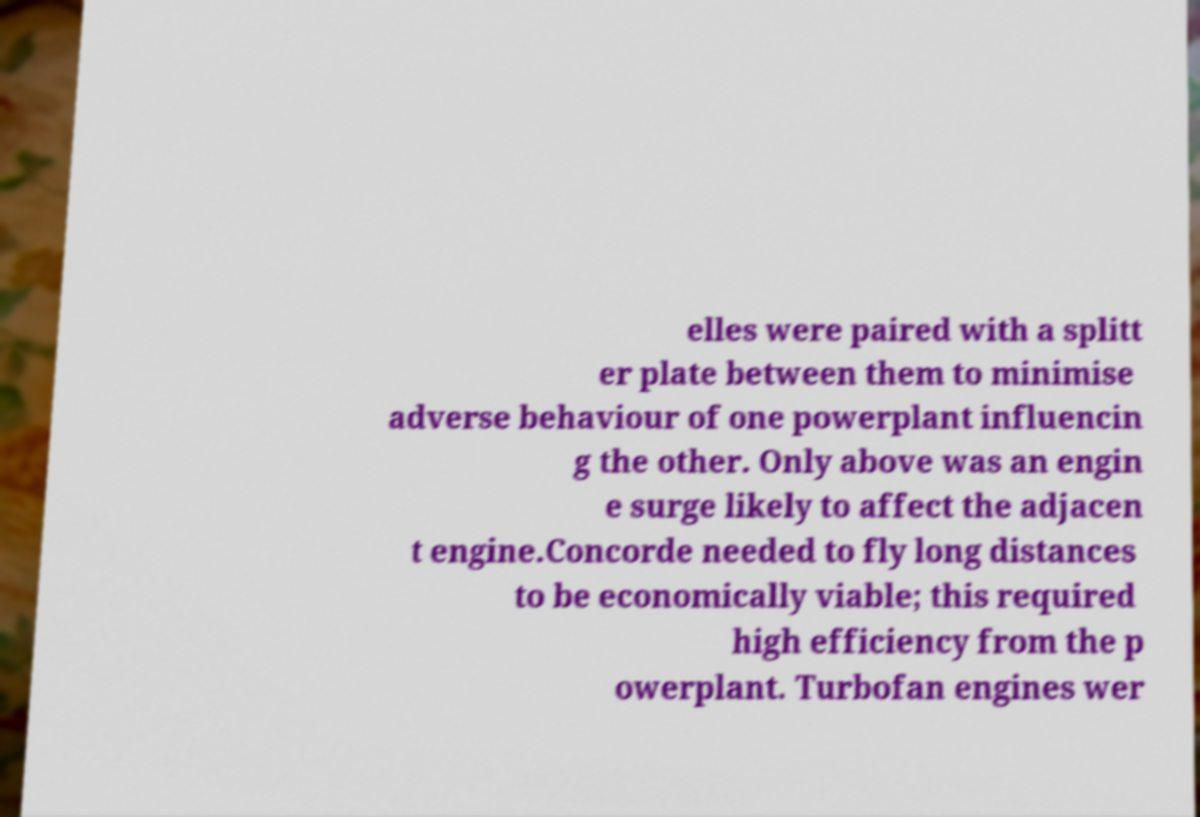For documentation purposes, I need the text within this image transcribed. Could you provide that? elles were paired with a splitt er plate between them to minimise adverse behaviour of one powerplant influencin g the other. Only above was an engin e surge likely to affect the adjacen t engine.Concorde needed to fly long distances to be economically viable; this required high efficiency from the p owerplant. Turbofan engines wer 